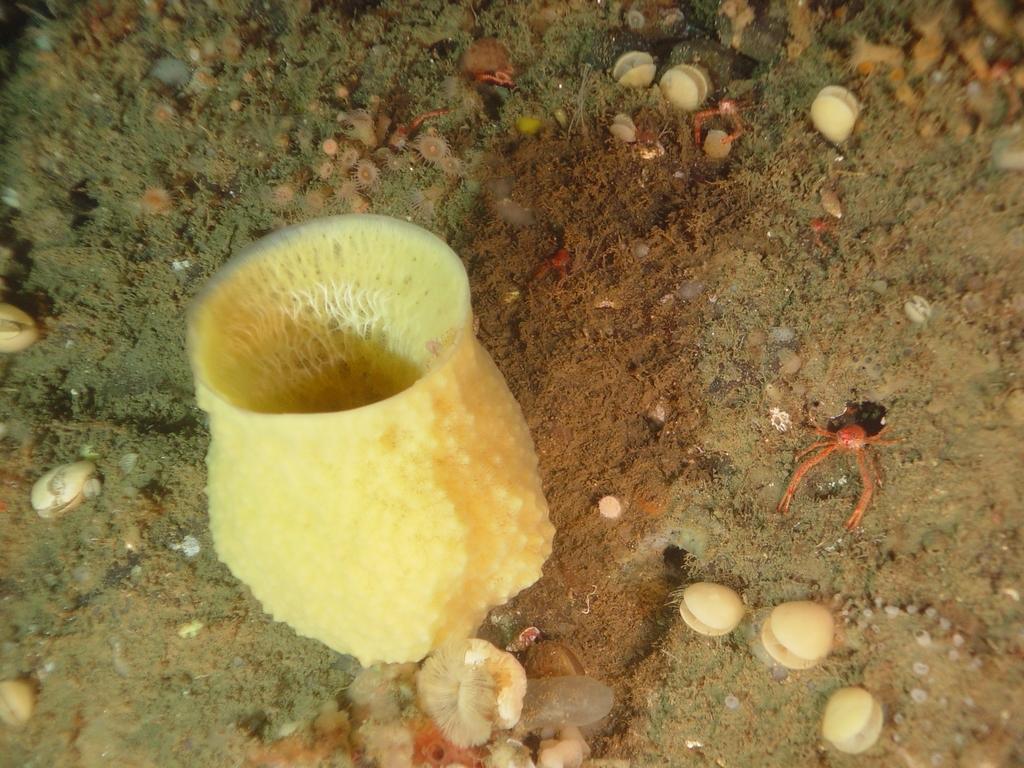In one or two sentences, can you explain what this image depicts? In this image we can see aquatic plants and animals. 